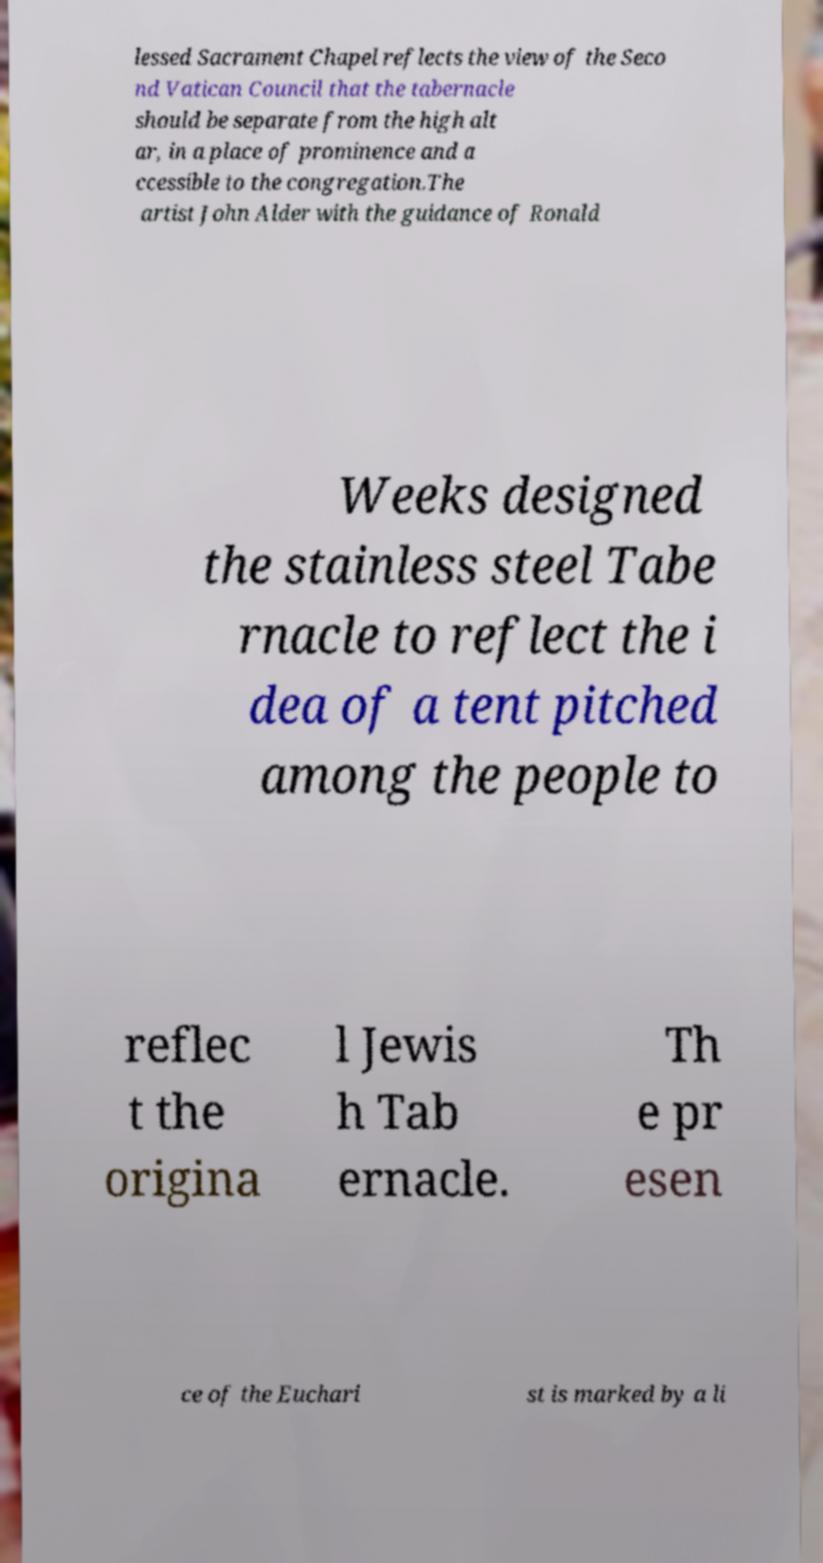Could you extract and type out the text from this image? lessed Sacrament Chapel reflects the view of the Seco nd Vatican Council that the tabernacle should be separate from the high alt ar, in a place of prominence and a ccessible to the congregation.The artist John Alder with the guidance of Ronald Weeks designed the stainless steel Tabe rnacle to reflect the i dea of a tent pitched among the people to reflec t the origina l Jewis h Tab ernacle. Th e pr esen ce of the Euchari st is marked by a li 